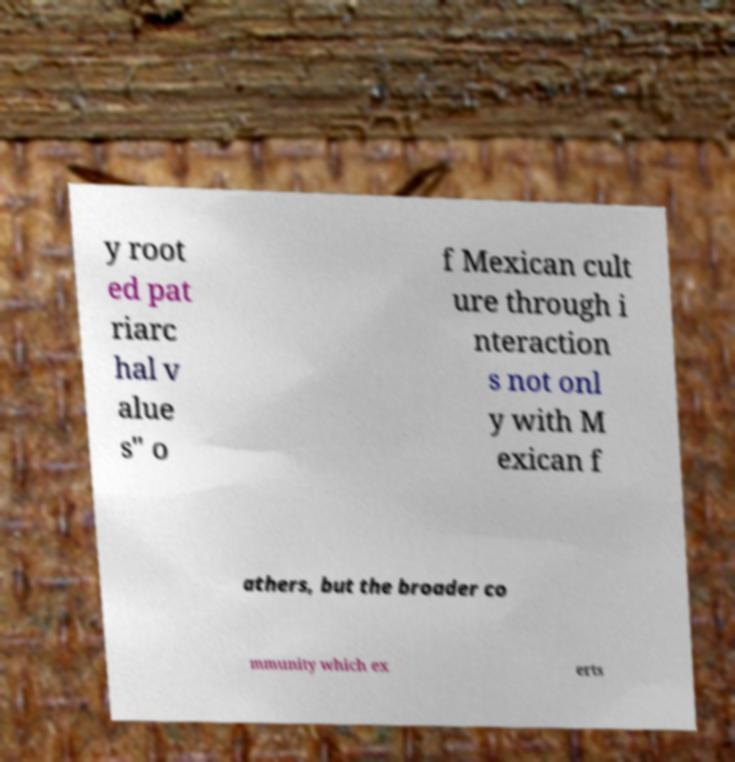Could you extract and type out the text from this image? y root ed pat riarc hal v alue s" o f Mexican cult ure through i nteraction s not onl y with M exican f athers, but the broader co mmunity which ex erts 